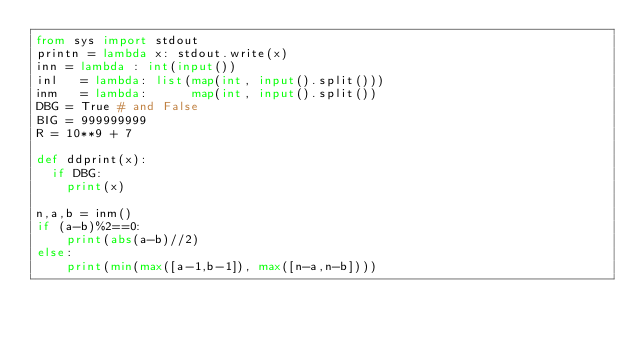<code> <loc_0><loc_0><loc_500><loc_500><_Python_>from sys import stdout
printn = lambda x: stdout.write(x)
inn = lambda : int(input())
inl   = lambda: list(map(int, input().split()))
inm   = lambda:      map(int, input().split())
DBG = True # and False
BIG = 999999999
R = 10**9 + 7

def ddprint(x):
  if DBG:
    print(x)

n,a,b = inm()
if (a-b)%2==0:
    print(abs(a-b)//2)
else:
    print(min(max([a-1,b-1]), max([n-a,n-b])))
</code> 